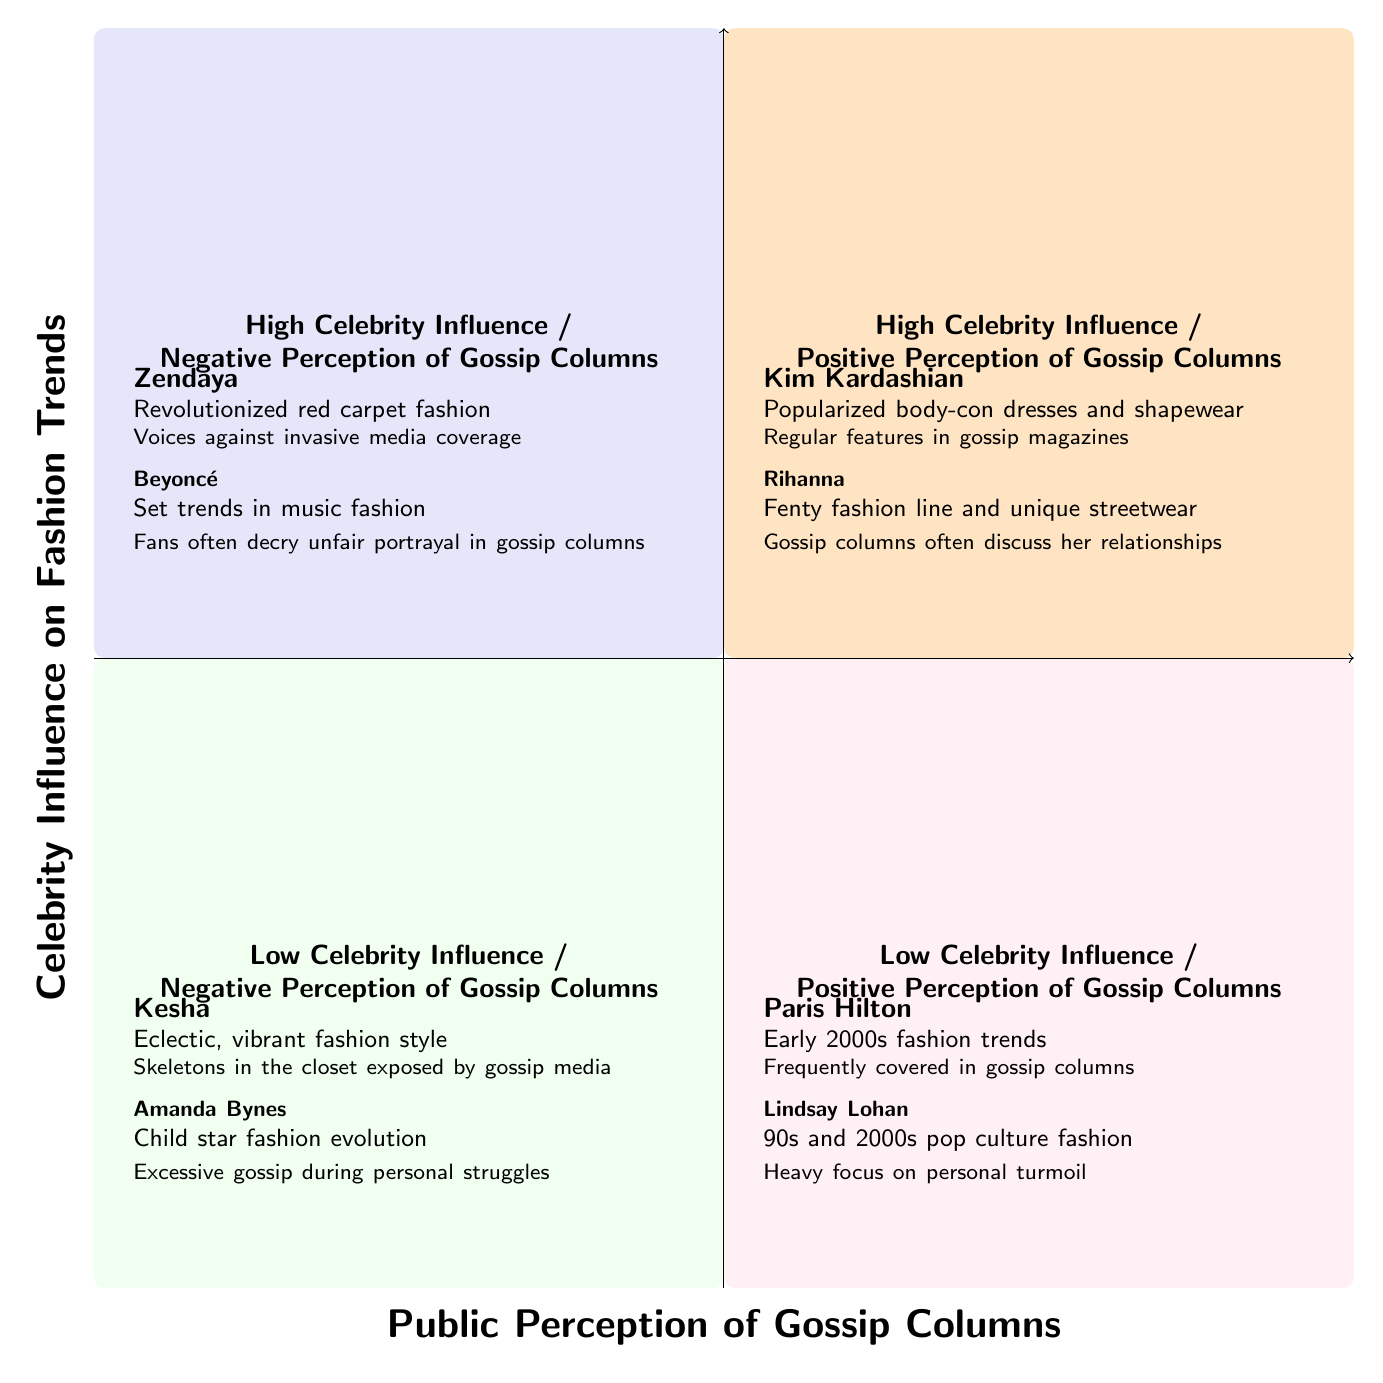What celebrities are in the quadrant for High Celebrity Influence / Positive Perception of Gossip Columns? The quadrant labeled "High Celebrity Influence / Positive Perception of Gossip Columns" contains two celebrities: Kim Kardashian and Rihanna.
Answer: Kim Kardashian, Rihanna How many elements are in the Low Celebrity Influence / Negative Perception of Gossip Columns quadrant? The quadrant for "Low Celebrity Influence / Negative Perception of Gossip Columns" includes two elements: Kesha and Amanda Bynes.
Answer: 2 What impact did Beyoncé have according to the diagram? Under the "High Celebrity Influence / Negative Perception of Gossip Columns" quadrant, Beyoncé is noted for setting trends in music fashion, particularly with leotards and bodysuits.
Answer: Set trends in music fashion, such as leotards and bodysuits How is public perception of Kim Kardashian described in the diagram? Kim Kardashian's public perception is described as shaped by her frequent media appearances, indicating a positive view influenced by her media presence.
Answer: Shaped by frequent media appearances Which celebrity is associated with an eclectic and vibrant fashion style? In the quadrant for "Low Celebrity Influence / Negative Perception of Gossip Columns," Kesha is noted for her eclectic and vibrant fashion style.
Answer: Kesha What general sentiment do fans have concerning Beyoncé's media coverage? Beyoncé's media coverage is often criticized, as fans typically decry the unfair portrayal found in gossip columns.
Answer: Fans often decry unfair portrayal in gossip columns What fashion trend is associated with Paris Hilton in the diagram? The diagram states that Paris Hilton was influential in early 2000s fashion trends, particularly with bedazzled accessories.
Answer: Early 2000s fashion trends, like bedazzled accessories How does the public generally perceive Amanda Bynes according to the chart? The public perception of Amanda Bynes is expressed as empathy over her excessive tabloid exploitation during personal struggles, indicating a sympathetic view.
Answer: General public empathy over tabloid exploitation What relationship exists between high celebrity influence and negative perception of gossip columns according to the diagram? The diagram shows that celebrities like Zendaya and Beyoncé have high celebrity influence, but their media portrayal is negatively perceived, leading to criticism from fans regarding the gossip columns.
Answer: High Celebrity Influence, Negative Perception of Gossip Columns 